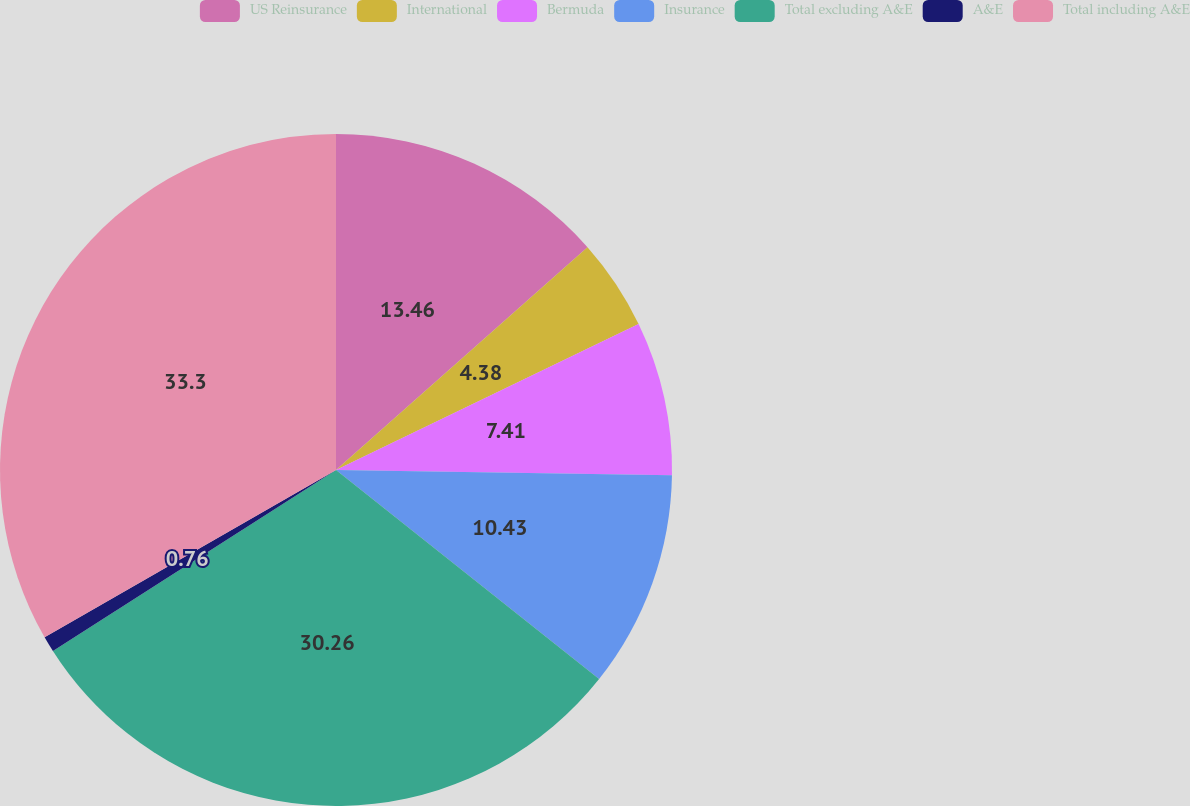Convert chart. <chart><loc_0><loc_0><loc_500><loc_500><pie_chart><fcel>US Reinsurance<fcel>International<fcel>Bermuda<fcel>Insurance<fcel>Total excluding A&E<fcel>A&E<fcel>Total including A&E<nl><fcel>13.46%<fcel>4.38%<fcel>7.41%<fcel>10.43%<fcel>30.26%<fcel>0.76%<fcel>33.29%<nl></chart> 